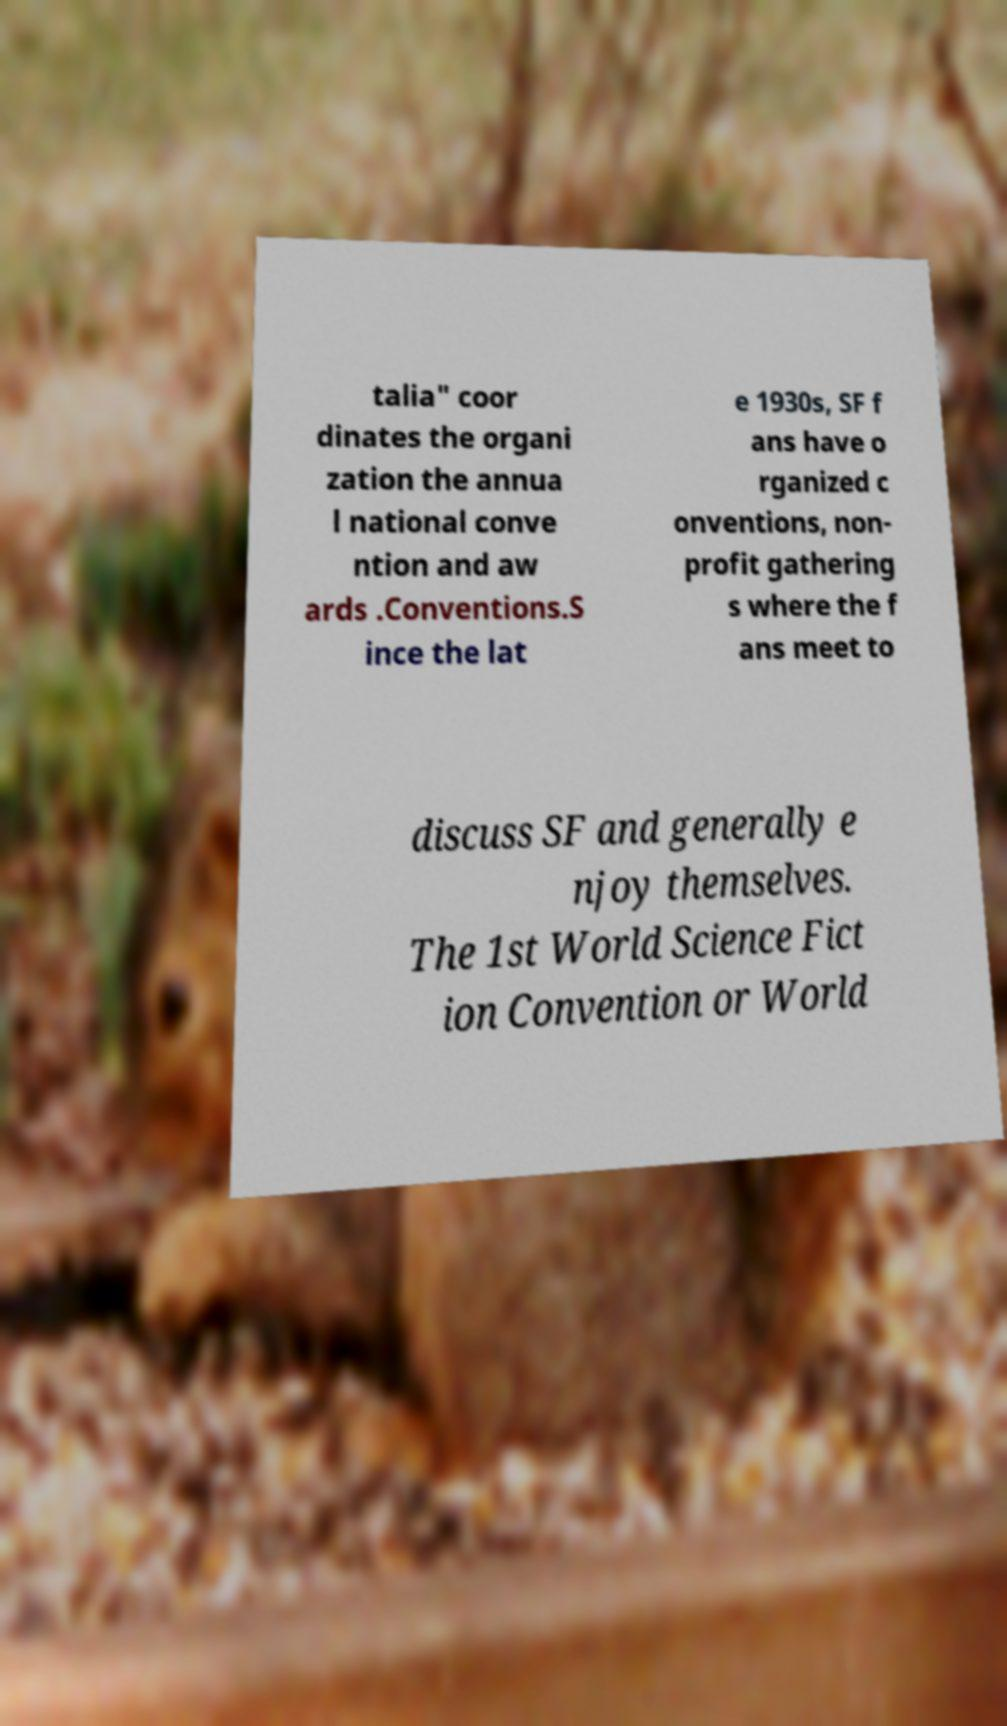I need the written content from this picture converted into text. Can you do that? talia" coor dinates the organi zation the annua l national conve ntion and aw ards .Conventions.S ince the lat e 1930s, SF f ans have o rganized c onventions, non- profit gathering s where the f ans meet to discuss SF and generally e njoy themselves. The 1st World Science Fict ion Convention or World 